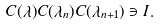<formula> <loc_0><loc_0><loc_500><loc_500>C ( \lambda ) C ( \lambda _ { n } ) C ( \lambda _ { n + 1 } ) \ni I .</formula> 